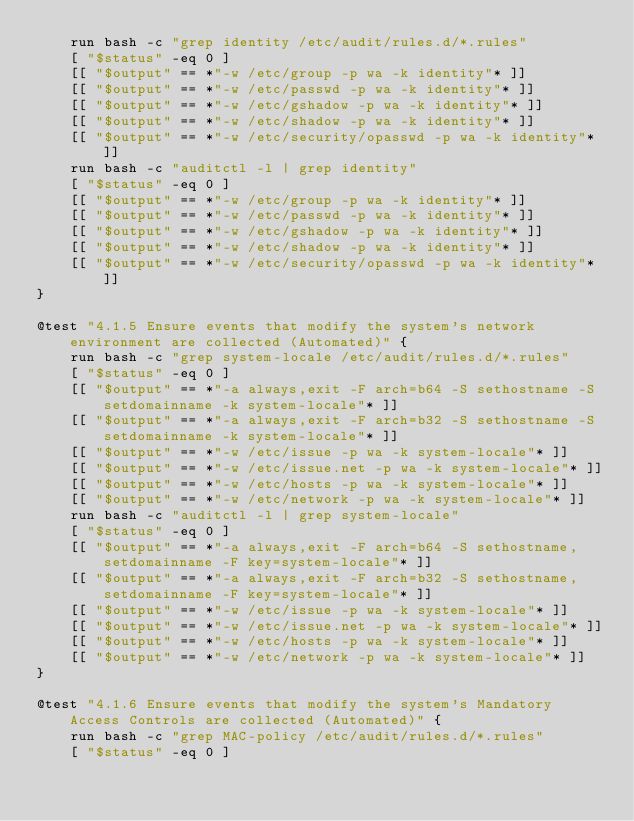<code> <loc_0><loc_0><loc_500><loc_500><_Bash_>    run bash -c "grep identity /etc/audit/rules.d/*.rules"
    [ "$status" -eq 0 ]
    [[ "$output" == *"-w /etc/group -p wa -k identity"* ]]
    [[ "$output" == *"-w /etc/passwd -p wa -k identity"* ]]
    [[ "$output" == *"-w /etc/gshadow -p wa -k identity"* ]]
    [[ "$output" == *"-w /etc/shadow -p wa -k identity"* ]]
    [[ "$output" == *"-w /etc/security/opasswd -p wa -k identity"* ]]
    run bash -c "auditctl -l | grep identity"
    [ "$status" -eq 0 ]
    [[ "$output" == *"-w /etc/group -p wa -k identity"* ]]
    [[ "$output" == *"-w /etc/passwd -p wa -k identity"* ]]
    [[ "$output" == *"-w /etc/gshadow -p wa -k identity"* ]]
    [[ "$output" == *"-w /etc/shadow -p wa -k identity"* ]]
    [[ "$output" == *"-w /etc/security/opasswd -p wa -k identity"* ]]
}

@test "4.1.5 Ensure events that modify the system's network environment are collected (Automated)" {
    run bash -c "grep system-locale /etc/audit/rules.d/*.rules"
    [ "$status" -eq 0 ]
    [[ "$output" == *"-a always,exit -F arch=b64 -S sethostname -S setdomainname -k system-locale"* ]]
    [[ "$output" == *"-a always,exit -F arch=b32 -S sethostname -S setdomainname -k system-locale"* ]]
    [[ "$output" == *"-w /etc/issue -p wa -k system-locale"* ]]
    [[ "$output" == *"-w /etc/issue.net -p wa -k system-locale"* ]]
    [[ "$output" == *"-w /etc/hosts -p wa -k system-locale"* ]]
    [[ "$output" == *"-w /etc/network -p wa -k system-locale"* ]]
    run bash -c "auditctl -l | grep system-locale"
    [ "$status" -eq 0 ]
    [[ "$output" == *"-a always,exit -F arch=b64 -S sethostname,setdomainname -F key=system-locale"* ]]
    [[ "$output" == *"-a always,exit -F arch=b32 -S sethostname,setdomainname -F key=system-locale"* ]]
    [[ "$output" == *"-w /etc/issue -p wa -k system-locale"* ]]
    [[ "$output" == *"-w /etc/issue.net -p wa -k system-locale"* ]]
    [[ "$output" == *"-w /etc/hosts -p wa -k system-locale"* ]]
    [[ "$output" == *"-w /etc/network -p wa -k system-locale"* ]]
}

@test "4.1.6 Ensure events that modify the system's Mandatory Access Controls are collected (Automated)" {
    run bash -c "grep MAC-policy /etc/audit/rules.d/*.rules"
    [ "$status" -eq 0 ]</code> 